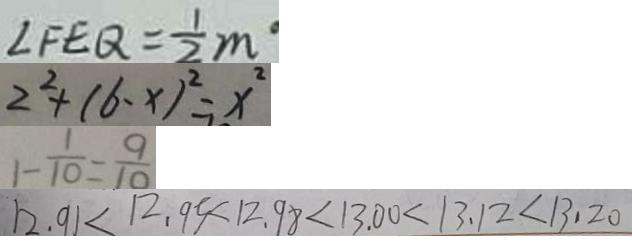<formula> <loc_0><loc_0><loc_500><loc_500>\angle F E Q = \frac { 1 } { 2 } m \cdot 
 2 ^ { 2 } + ( 6 - x ) ^ { 2 } = x ^ { 2 } 
 1 - \frac { 1 } { 1 0 } = \frac { 9 } { 1 0 } 
 1 2 . 9 1 < 1 2 . 9 5 < 1 2 . 9 8 < 1 3 . 0 0 < 1 3 . 1 2 < 1 3 . 2 0</formula> 